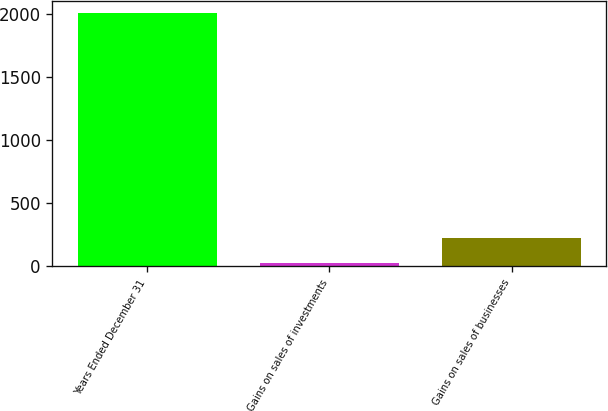Convert chart. <chart><loc_0><loc_0><loc_500><loc_500><bar_chart><fcel>Years Ended December 31<fcel>Gains on sales of investments<fcel>Gains on sales of businesses<nl><fcel>2002<fcel>27<fcel>224.5<nl></chart> 